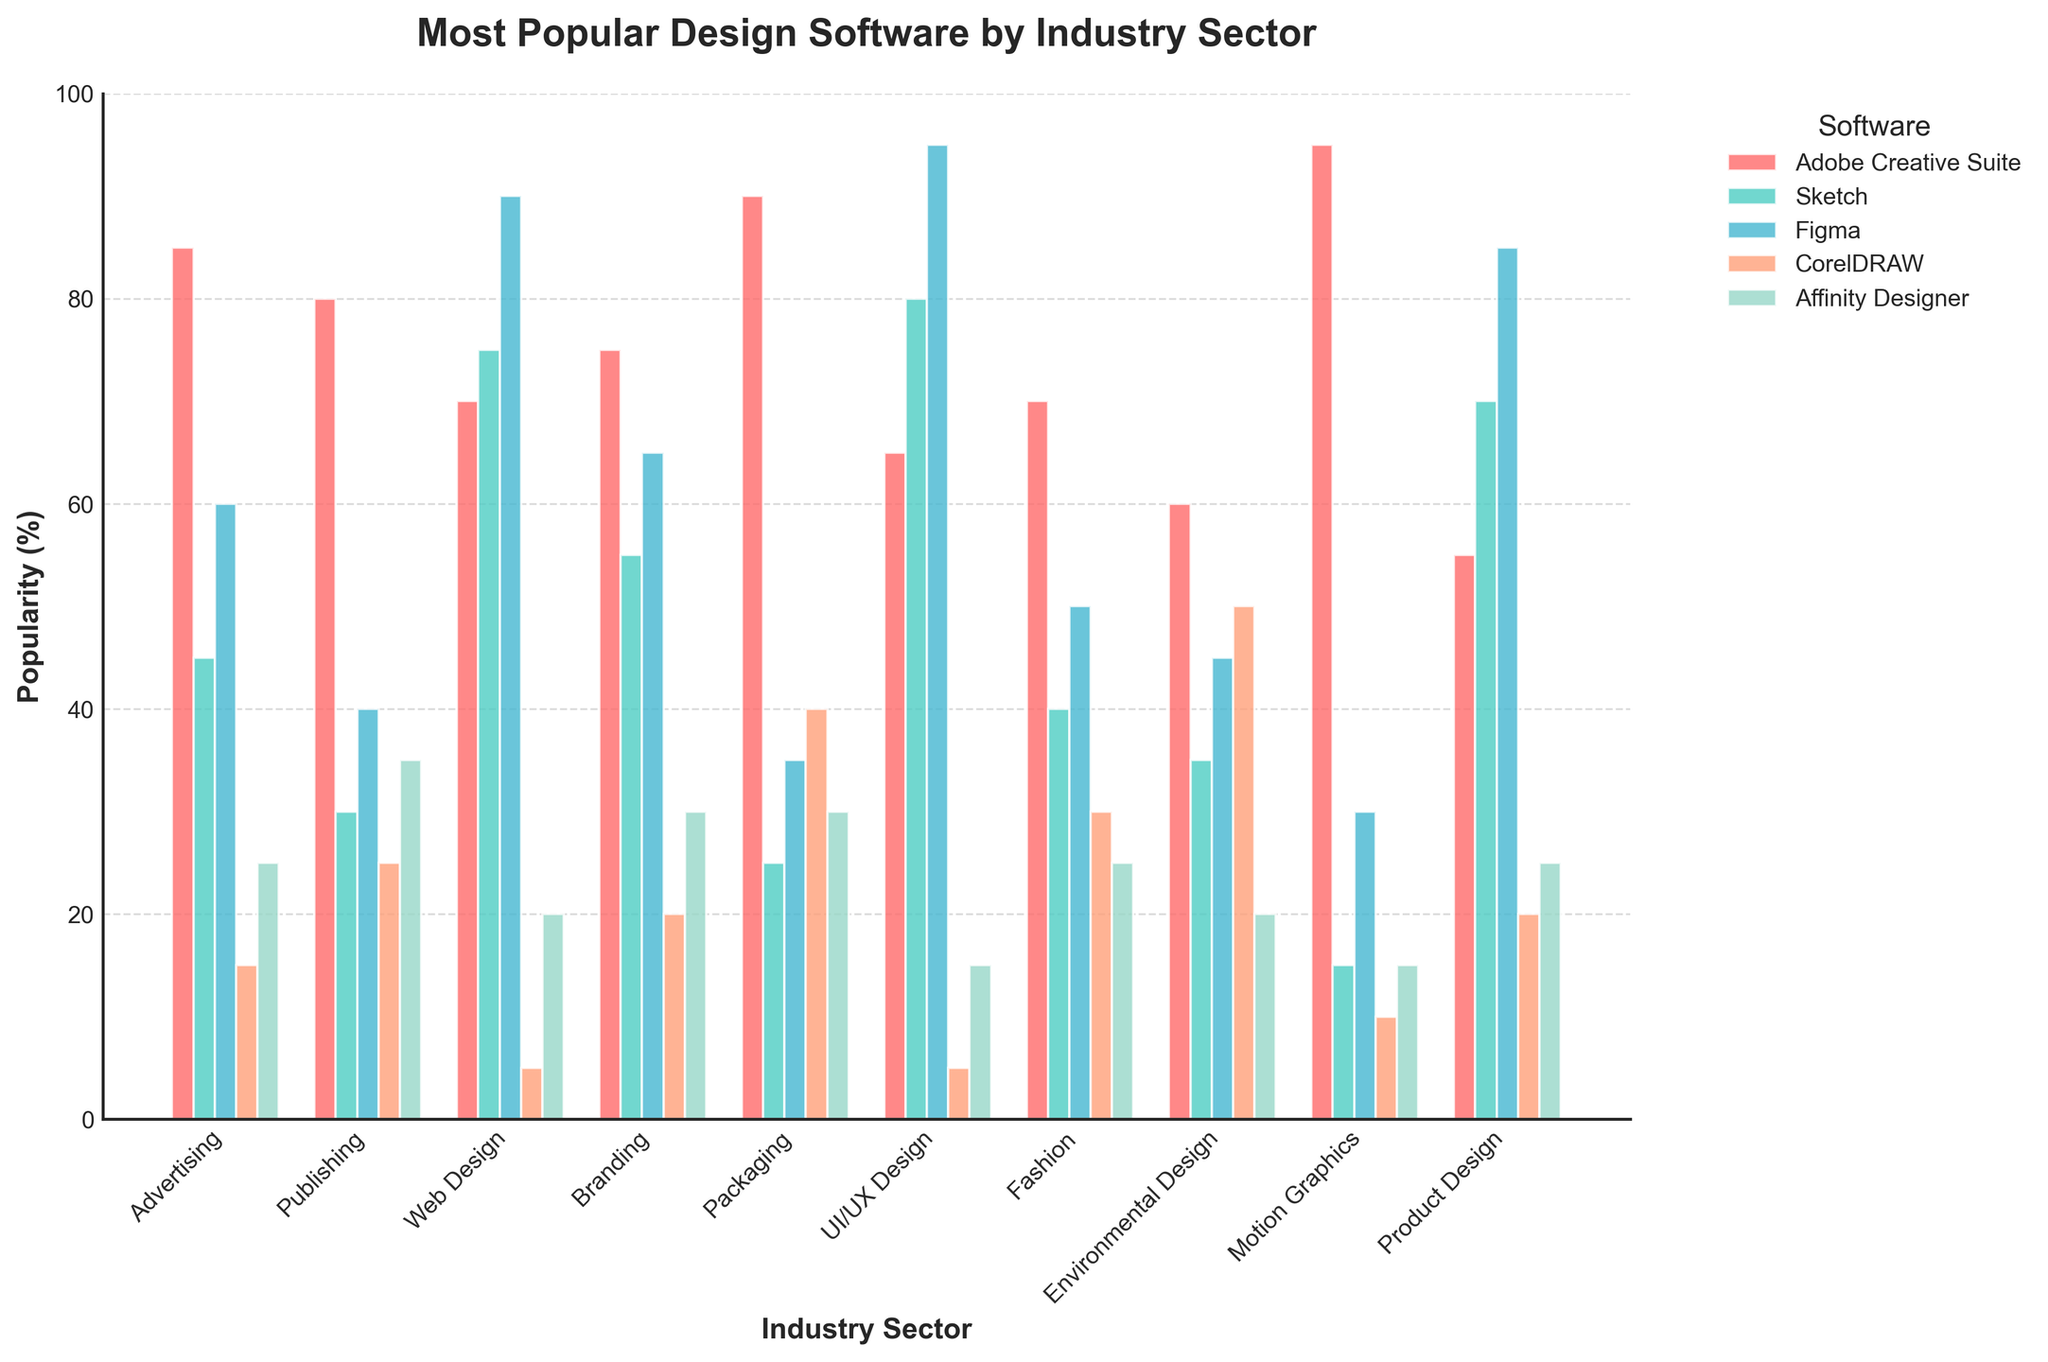Which software is the most popular in the Advertising sector? The Advertising sector's highest bar corresponds to Adobe Creative Suite.
Answer: Adobe Creative Suite Which industry sector has the highest popularity for Affinity Designer? The highest bar for Affinity Designer is in the Publishing sector, at 35.
Answer: Publishing What's the total popularity of Adobe Creative Suite across Motion Graphics and Fashion? Sum the values for Adobe Creative Suite in Motion Graphics (95) and Fashion (70): 95 + 70 = 165.
Answer: 165 In which sector is CorelDRAW more popular than Adobe Creative Suite? Compare CorelDRAW and Adobe Creative Suite in each sector. CorelDRAW only exceeds Adobe Creative Suite in Environmental Design.
Answer: Environmental Design What is the difference in popularity of Sketch between UI/UX Design and Web Design? Subtract Sketch's value in Web Design (75) from its value in UI/UX Design (80): 80 - 75 = 5.
Answer: 5 In the Branding sector, how does the popularity of Affinity Designer compare to CorelDRAW? Affinity Designer's popularity in Branding is 30, while CorelDRAW is 20. 30 > 20.
Answer: Affinity Designer is more popular than CorelDRAW in Branding What is the average popularity of Figma in Advertising, UI/UX Design, and Motion Graphics? Sum the values of Figma in these sectors and divide by three: (60 + 95 + 30) = 185 / 3 ≈ 61.67
Answer: 61.67 